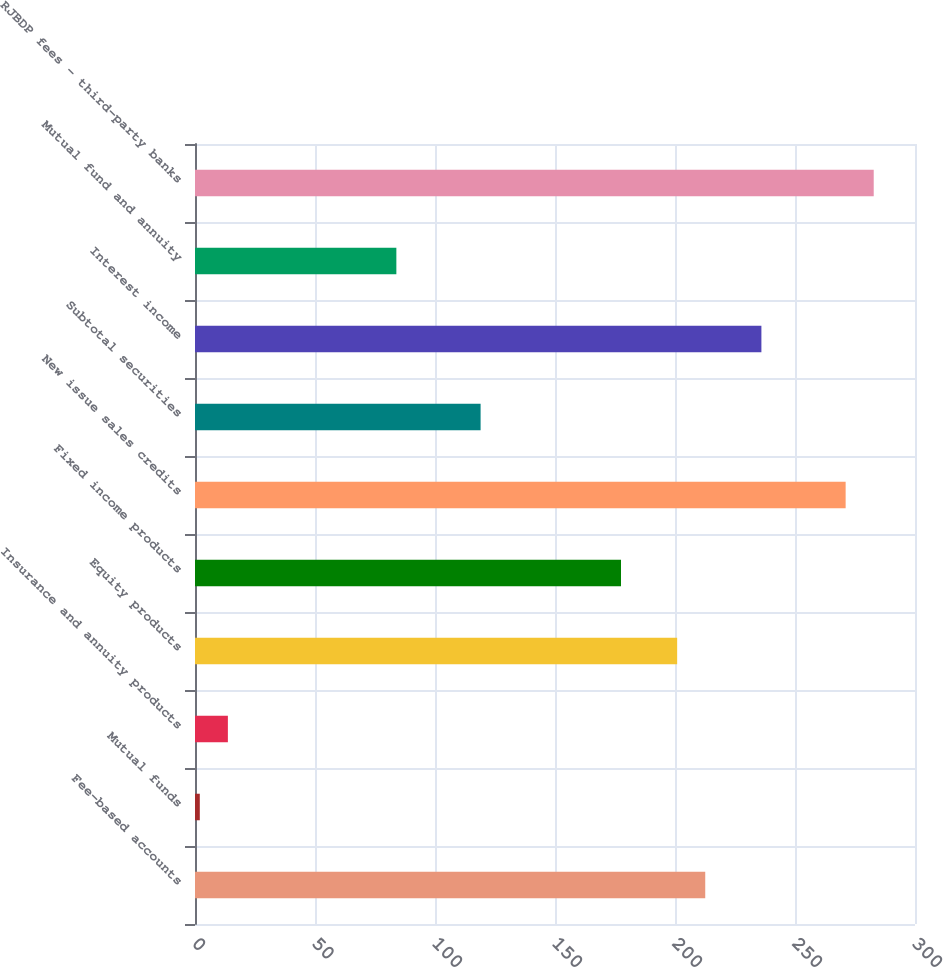Convert chart to OTSL. <chart><loc_0><loc_0><loc_500><loc_500><bar_chart><fcel>Fee-based accounts<fcel>Mutual funds<fcel>Insurance and annuity products<fcel>Equity products<fcel>Fixed income products<fcel>New issue sales credits<fcel>Subtotal securities<fcel>Interest income<fcel>Mutual fund and annuity<fcel>RJBDP fees - third-party banks<nl><fcel>212.6<fcel>2<fcel>13.7<fcel>200.9<fcel>177.5<fcel>271.1<fcel>119<fcel>236<fcel>83.9<fcel>282.8<nl></chart> 